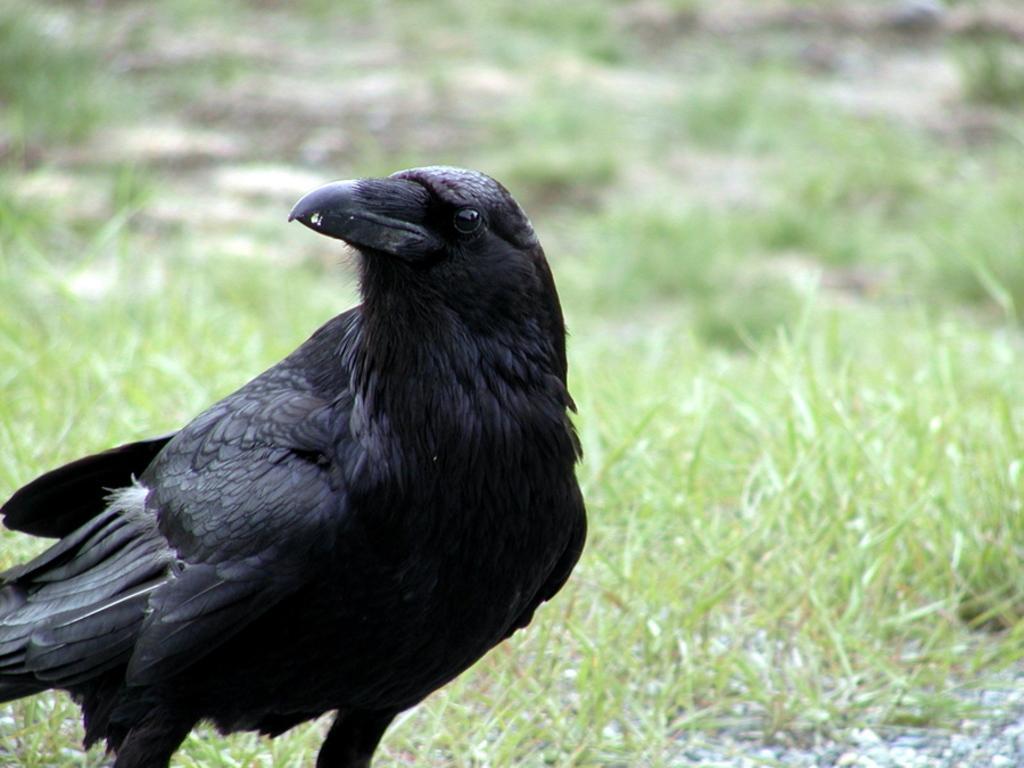How would you summarize this image in a sentence or two? In this picture, we see a crow. It is in black color. In the background, we see the grass. It is blurred in the background. 